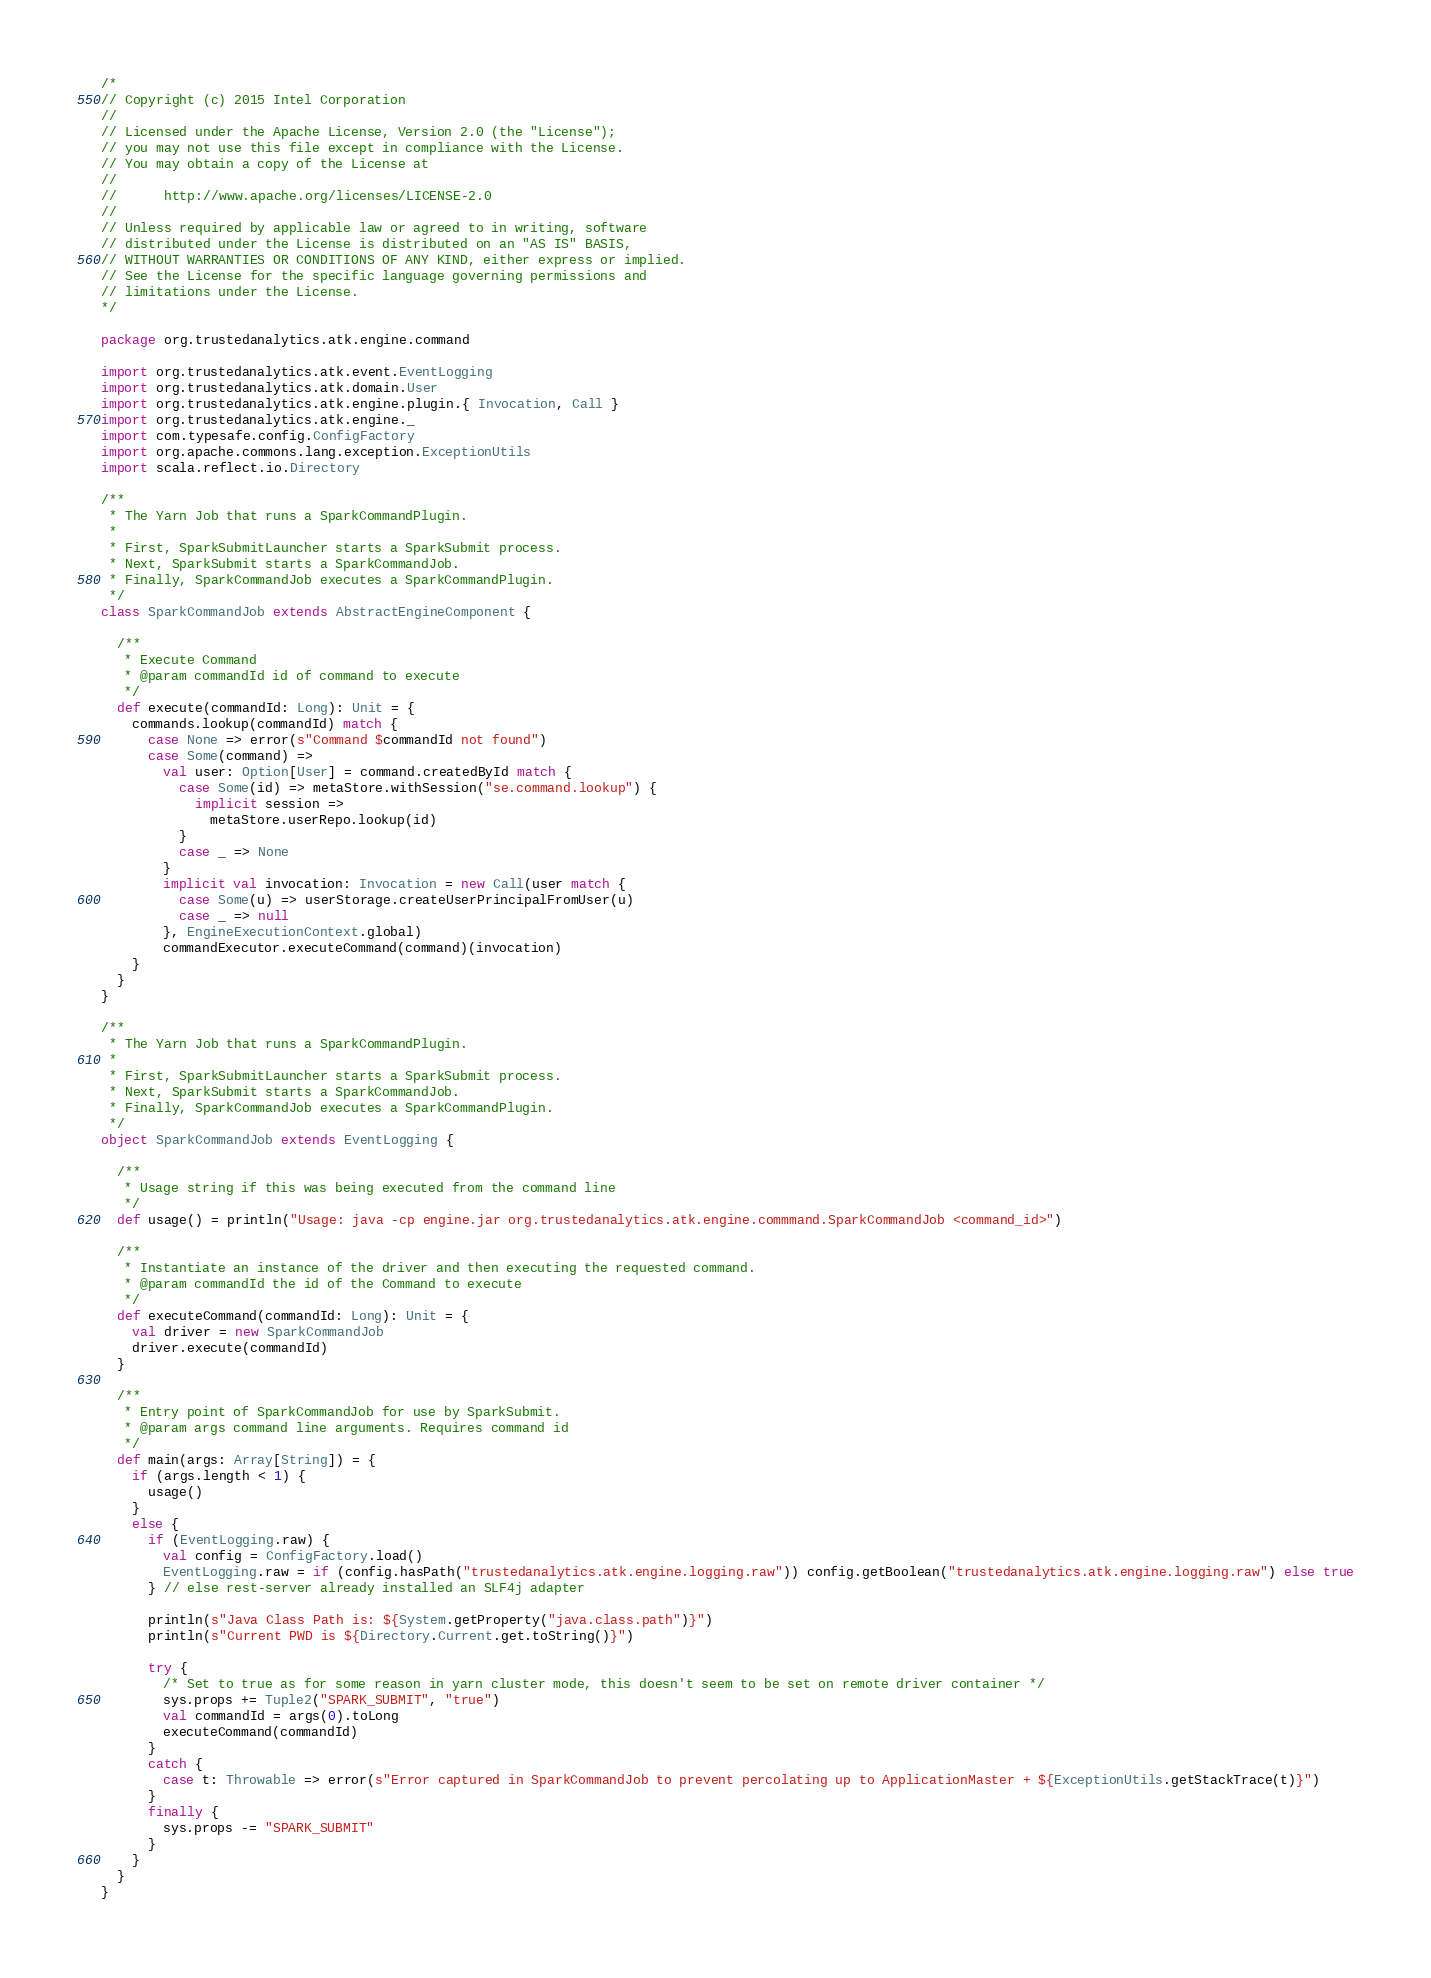<code> <loc_0><loc_0><loc_500><loc_500><_Scala_>/*
// Copyright (c) 2015 Intel Corporation 
//
// Licensed under the Apache License, Version 2.0 (the "License");
// you may not use this file except in compliance with the License.
// You may obtain a copy of the License at
//
//      http://www.apache.org/licenses/LICENSE-2.0
//
// Unless required by applicable law or agreed to in writing, software
// distributed under the License is distributed on an "AS IS" BASIS,
// WITHOUT WARRANTIES OR CONDITIONS OF ANY KIND, either express or implied.
// See the License for the specific language governing permissions and
// limitations under the License.
*/

package org.trustedanalytics.atk.engine.command

import org.trustedanalytics.atk.event.EventLogging
import org.trustedanalytics.atk.domain.User
import org.trustedanalytics.atk.engine.plugin.{ Invocation, Call }
import org.trustedanalytics.atk.engine._
import com.typesafe.config.ConfigFactory
import org.apache.commons.lang.exception.ExceptionUtils
import scala.reflect.io.Directory

/**
 * The Yarn Job that runs a SparkCommandPlugin.
 *
 * First, SparkSubmitLauncher starts a SparkSubmit process.
 * Next, SparkSubmit starts a SparkCommandJob.
 * Finally, SparkCommandJob executes a SparkCommandPlugin.
 */
class SparkCommandJob extends AbstractEngineComponent {

  /**
   * Execute Command
   * @param commandId id of command to execute
   */
  def execute(commandId: Long): Unit = {
    commands.lookup(commandId) match {
      case None => error(s"Command $commandId not found")
      case Some(command) =>
        val user: Option[User] = command.createdById match {
          case Some(id) => metaStore.withSession("se.command.lookup") {
            implicit session =>
              metaStore.userRepo.lookup(id)
          }
          case _ => None
        }
        implicit val invocation: Invocation = new Call(user match {
          case Some(u) => userStorage.createUserPrincipalFromUser(u)
          case _ => null
        }, EngineExecutionContext.global)
        commandExecutor.executeCommand(command)(invocation)
    }
  }
}

/**
 * The Yarn Job that runs a SparkCommandPlugin.
 *
 * First, SparkSubmitLauncher starts a SparkSubmit process.
 * Next, SparkSubmit starts a SparkCommandJob.
 * Finally, SparkCommandJob executes a SparkCommandPlugin.
 */
object SparkCommandJob extends EventLogging {

  /**
   * Usage string if this was being executed from the command line
   */
  def usage() = println("Usage: java -cp engine.jar org.trustedanalytics.atk.engine.commmand.SparkCommandJob <command_id>")

  /**
   * Instantiate an instance of the driver and then executing the requested command.
   * @param commandId the id of the Command to execute
   */
  def executeCommand(commandId: Long): Unit = {
    val driver = new SparkCommandJob
    driver.execute(commandId)
  }

  /**
   * Entry point of SparkCommandJob for use by SparkSubmit.
   * @param args command line arguments. Requires command id
   */
  def main(args: Array[String]) = {
    if (args.length < 1) {
      usage()
    }
    else {
      if (EventLogging.raw) {
        val config = ConfigFactory.load()
        EventLogging.raw = if (config.hasPath("trustedanalytics.atk.engine.logging.raw")) config.getBoolean("trustedanalytics.atk.engine.logging.raw") else true
      } // else rest-server already installed an SLF4j adapter

      println(s"Java Class Path is: ${System.getProperty("java.class.path")}")
      println(s"Current PWD is ${Directory.Current.get.toString()}")

      try {
        /* Set to true as for some reason in yarn cluster mode, this doesn't seem to be set on remote driver container */
        sys.props += Tuple2("SPARK_SUBMIT", "true")
        val commandId = args(0).toLong
        executeCommand(commandId)
      }
      catch {
        case t: Throwable => error(s"Error captured in SparkCommandJob to prevent percolating up to ApplicationMaster + ${ExceptionUtils.getStackTrace(t)}")
      }
      finally {
        sys.props -= "SPARK_SUBMIT"
      }
    }
  }
}
</code> 